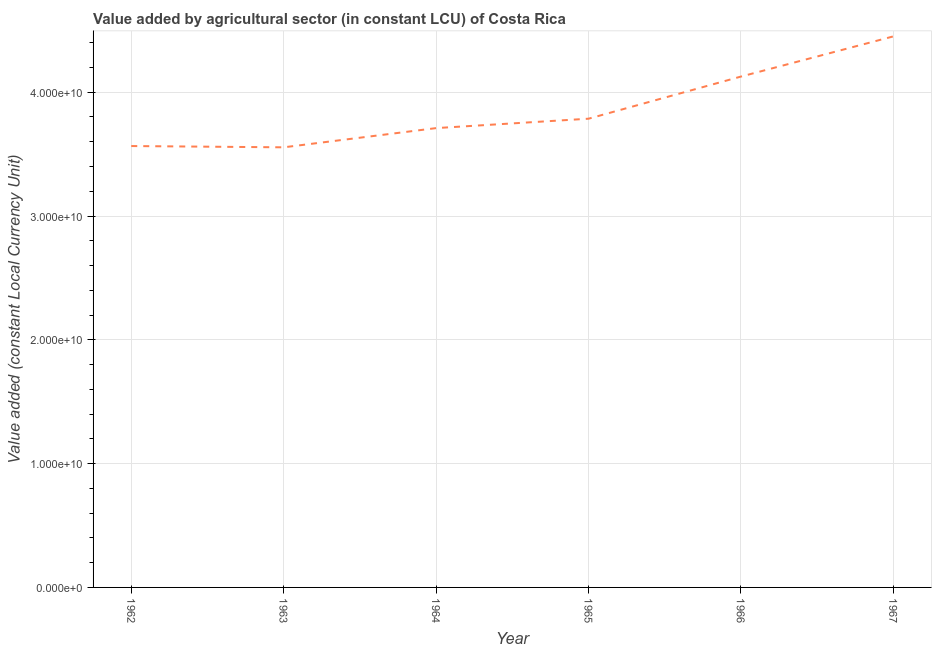What is the value added by agriculture sector in 1966?
Provide a short and direct response. 4.13e+1. Across all years, what is the maximum value added by agriculture sector?
Your response must be concise. 4.45e+1. Across all years, what is the minimum value added by agriculture sector?
Make the answer very short. 3.56e+1. In which year was the value added by agriculture sector maximum?
Your response must be concise. 1967. In which year was the value added by agriculture sector minimum?
Offer a terse response. 1963. What is the sum of the value added by agriculture sector?
Give a very brief answer. 2.32e+11. What is the difference between the value added by agriculture sector in 1966 and 1967?
Offer a very short reply. -3.25e+09. What is the average value added by agriculture sector per year?
Give a very brief answer. 3.87e+1. What is the median value added by agriculture sector?
Offer a terse response. 3.75e+1. Do a majority of the years between 1966 and 1962 (inclusive) have value added by agriculture sector greater than 24000000000 LCU?
Keep it short and to the point. Yes. What is the ratio of the value added by agriculture sector in 1962 to that in 1964?
Your answer should be very brief. 0.96. Is the difference between the value added by agriculture sector in 1963 and 1966 greater than the difference between any two years?
Your response must be concise. No. What is the difference between the highest and the second highest value added by agriculture sector?
Provide a short and direct response. 3.25e+09. Is the sum of the value added by agriculture sector in 1966 and 1967 greater than the maximum value added by agriculture sector across all years?
Offer a very short reply. Yes. What is the difference between the highest and the lowest value added by agriculture sector?
Your answer should be very brief. 8.96e+09. How many years are there in the graph?
Provide a short and direct response. 6. What is the difference between two consecutive major ticks on the Y-axis?
Keep it short and to the point. 1.00e+1. What is the title of the graph?
Provide a succinct answer. Value added by agricultural sector (in constant LCU) of Costa Rica. What is the label or title of the X-axis?
Offer a terse response. Year. What is the label or title of the Y-axis?
Ensure brevity in your answer.  Value added (constant Local Currency Unit). What is the Value added (constant Local Currency Unit) of 1962?
Make the answer very short. 3.57e+1. What is the Value added (constant Local Currency Unit) in 1963?
Keep it short and to the point. 3.56e+1. What is the Value added (constant Local Currency Unit) in 1964?
Offer a very short reply. 3.71e+1. What is the Value added (constant Local Currency Unit) in 1965?
Keep it short and to the point. 3.79e+1. What is the Value added (constant Local Currency Unit) in 1966?
Make the answer very short. 4.13e+1. What is the Value added (constant Local Currency Unit) in 1967?
Keep it short and to the point. 4.45e+1. What is the difference between the Value added (constant Local Currency Unit) in 1962 and 1963?
Provide a succinct answer. 1.04e+08. What is the difference between the Value added (constant Local Currency Unit) in 1962 and 1964?
Offer a very short reply. -1.45e+09. What is the difference between the Value added (constant Local Currency Unit) in 1962 and 1965?
Your response must be concise. -2.21e+09. What is the difference between the Value added (constant Local Currency Unit) in 1962 and 1966?
Offer a very short reply. -5.61e+09. What is the difference between the Value added (constant Local Currency Unit) in 1962 and 1967?
Make the answer very short. -8.86e+09. What is the difference between the Value added (constant Local Currency Unit) in 1963 and 1964?
Your response must be concise. -1.55e+09. What is the difference between the Value added (constant Local Currency Unit) in 1963 and 1965?
Ensure brevity in your answer.  -2.31e+09. What is the difference between the Value added (constant Local Currency Unit) in 1963 and 1966?
Ensure brevity in your answer.  -5.72e+09. What is the difference between the Value added (constant Local Currency Unit) in 1963 and 1967?
Offer a very short reply. -8.96e+09. What is the difference between the Value added (constant Local Currency Unit) in 1964 and 1965?
Your answer should be compact. -7.60e+08. What is the difference between the Value added (constant Local Currency Unit) in 1964 and 1966?
Your response must be concise. -4.16e+09. What is the difference between the Value added (constant Local Currency Unit) in 1964 and 1967?
Ensure brevity in your answer.  -7.41e+09. What is the difference between the Value added (constant Local Currency Unit) in 1965 and 1966?
Make the answer very short. -3.40e+09. What is the difference between the Value added (constant Local Currency Unit) in 1965 and 1967?
Give a very brief answer. -6.65e+09. What is the difference between the Value added (constant Local Currency Unit) in 1966 and 1967?
Make the answer very short. -3.25e+09. What is the ratio of the Value added (constant Local Currency Unit) in 1962 to that in 1963?
Provide a short and direct response. 1. What is the ratio of the Value added (constant Local Currency Unit) in 1962 to that in 1964?
Give a very brief answer. 0.96. What is the ratio of the Value added (constant Local Currency Unit) in 1962 to that in 1965?
Make the answer very short. 0.94. What is the ratio of the Value added (constant Local Currency Unit) in 1962 to that in 1966?
Your answer should be compact. 0.86. What is the ratio of the Value added (constant Local Currency Unit) in 1962 to that in 1967?
Offer a terse response. 0.8. What is the ratio of the Value added (constant Local Currency Unit) in 1963 to that in 1964?
Give a very brief answer. 0.96. What is the ratio of the Value added (constant Local Currency Unit) in 1963 to that in 1965?
Provide a succinct answer. 0.94. What is the ratio of the Value added (constant Local Currency Unit) in 1963 to that in 1966?
Your answer should be compact. 0.86. What is the ratio of the Value added (constant Local Currency Unit) in 1963 to that in 1967?
Provide a succinct answer. 0.8. What is the ratio of the Value added (constant Local Currency Unit) in 1964 to that in 1966?
Ensure brevity in your answer.  0.9. What is the ratio of the Value added (constant Local Currency Unit) in 1964 to that in 1967?
Give a very brief answer. 0.83. What is the ratio of the Value added (constant Local Currency Unit) in 1965 to that in 1966?
Ensure brevity in your answer.  0.92. What is the ratio of the Value added (constant Local Currency Unit) in 1965 to that in 1967?
Keep it short and to the point. 0.85. What is the ratio of the Value added (constant Local Currency Unit) in 1966 to that in 1967?
Give a very brief answer. 0.93. 